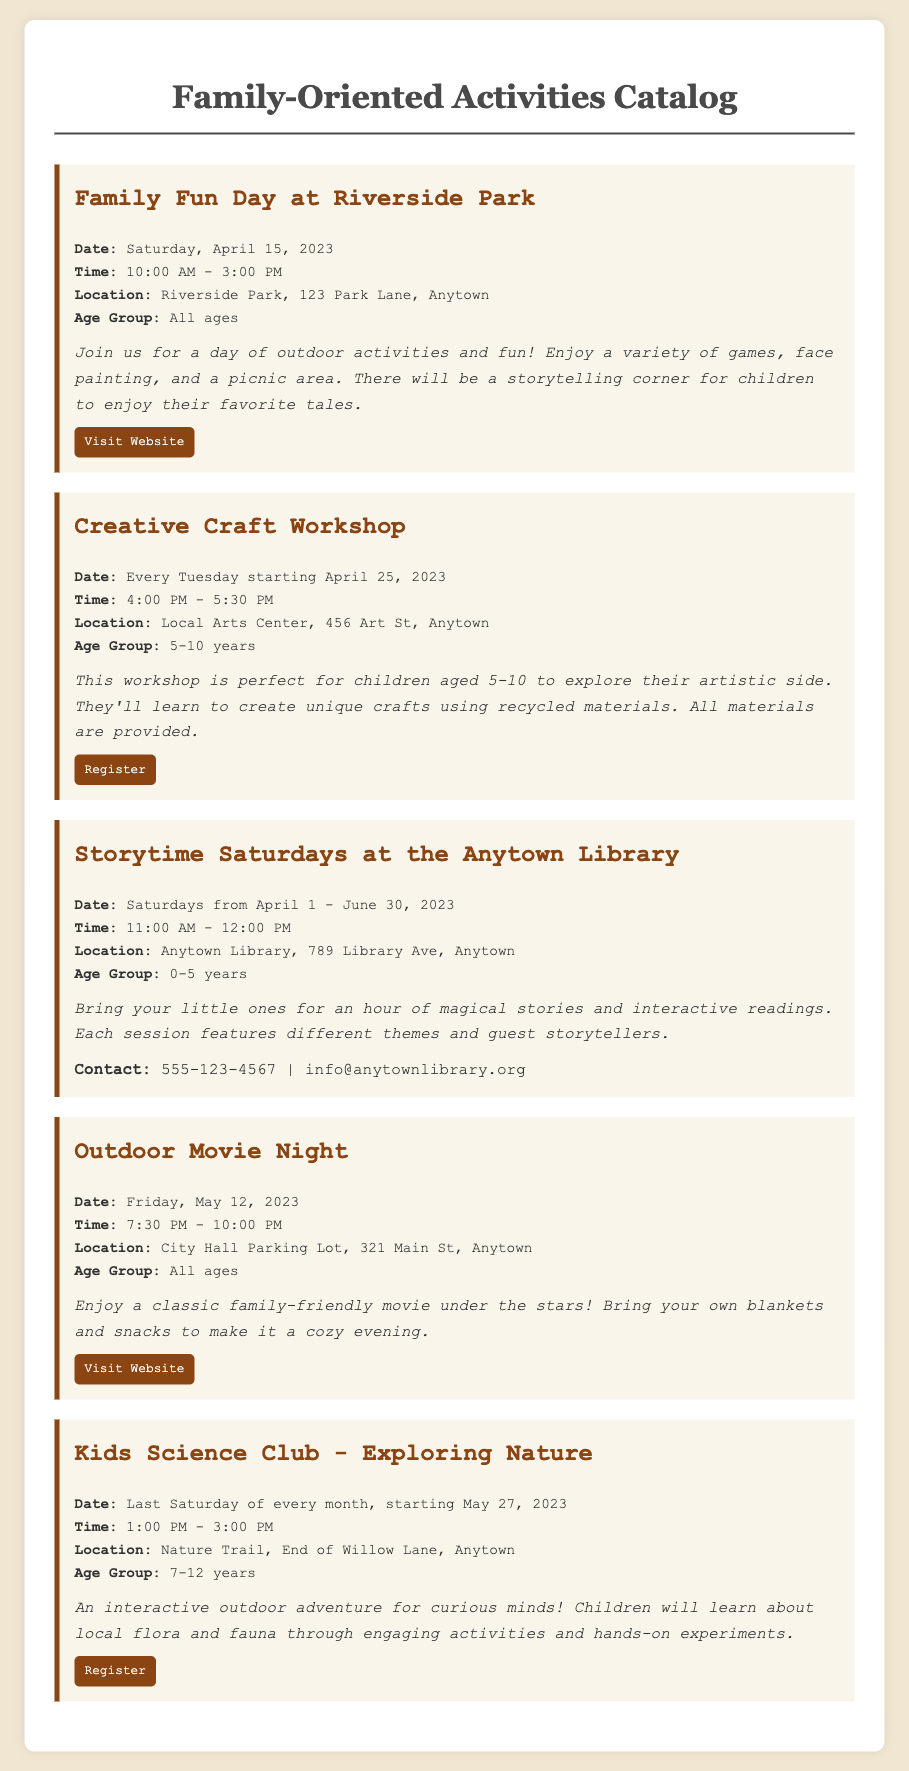What is the date of the Family Fun Day? The document lists the date for the Family Fun Day at Riverside Park as Saturday, April 15, 2023.
Answer: Saturday, April 15, 2023 What is the age group for the Creative Craft Workshop? According to the document, the age group for the Creative Craft Workshop is 5-10 years.
Answer: 5-10 years When does Storytime Saturdays take place? The document specifies that Storytime Saturdays at the Anytown Library occurs on Saturdays from April 1 to June 30, 2023.
Answer: Saturdays from April 1 - June 30, 2023 What activities are included in the Kids Science Club? The Kids Science Club includes activities related to learning about local flora and fauna through engaging activities and hands-on experiments.
Answer: Learning about local flora and fauna What is the time for the Outdoor Movie Night? The schedule for the Outdoor Movie Night indicates that it starts at 7:30 PM and ends at 10:00 PM.
Answer: 7:30 PM - 10:00 PM Which event has a storytelling corner? The description for the Family Fun Day at Riverside Park mentions a storytelling corner for children.
Answer: Family Fun Day at Riverside Park 